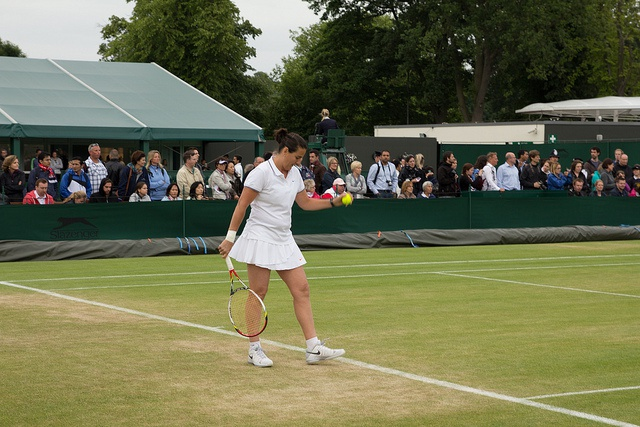Describe the objects in this image and their specific colors. I can see people in lightgray, black, gray, and maroon tones, people in lightgray, gray, darkgray, and tan tones, tennis racket in lightgray, olive, gray, and darkgray tones, people in lightgray, black, darkgray, and lavender tones, and people in lightgray, gray, black, and blue tones in this image. 